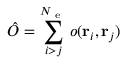<formula> <loc_0><loc_0><loc_500><loc_500>\hat { O } = \sum _ { i > j } ^ { N _ { e } } o ( { r _ { i } } , { r _ { j } } )</formula> 